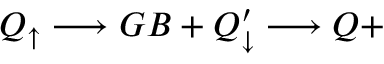<formula> <loc_0><loc_0><loc_500><loc_500>Q _ { \uparrow } \longrightarrow G B + Q _ { \downarrow } ^ { \prime } \longrightarrow Q +</formula> 